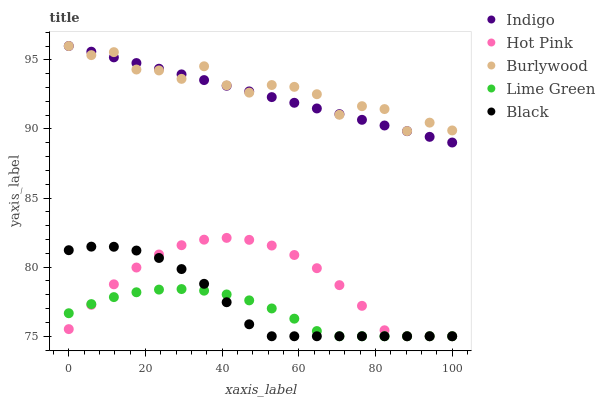Does Lime Green have the minimum area under the curve?
Answer yes or no. Yes. Does Burlywood have the maximum area under the curve?
Answer yes or no. Yes. Does Hot Pink have the minimum area under the curve?
Answer yes or no. No. Does Hot Pink have the maximum area under the curve?
Answer yes or no. No. Is Indigo the smoothest?
Answer yes or no. Yes. Is Burlywood the roughest?
Answer yes or no. Yes. Is Lime Green the smoothest?
Answer yes or no. No. Is Lime Green the roughest?
Answer yes or no. No. Does Lime Green have the lowest value?
Answer yes or no. Yes. Does Indigo have the lowest value?
Answer yes or no. No. Does Indigo have the highest value?
Answer yes or no. Yes. Does Hot Pink have the highest value?
Answer yes or no. No. Is Hot Pink less than Burlywood?
Answer yes or no. Yes. Is Burlywood greater than Lime Green?
Answer yes or no. Yes. Does Black intersect Hot Pink?
Answer yes or no. Yes. Is Black less than Hot Pink?
Answer yes or no. No. Is Black greater than Hot Pink?
Answer yes or no. No. Does Hot Pink intersect Burlywood?
Answer yes or no. No. 